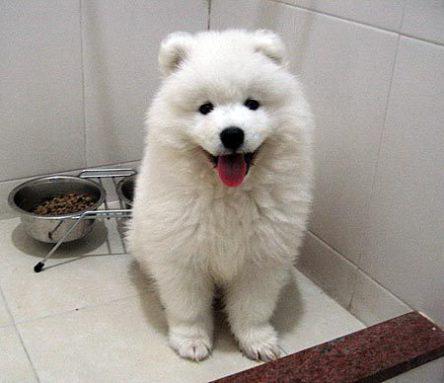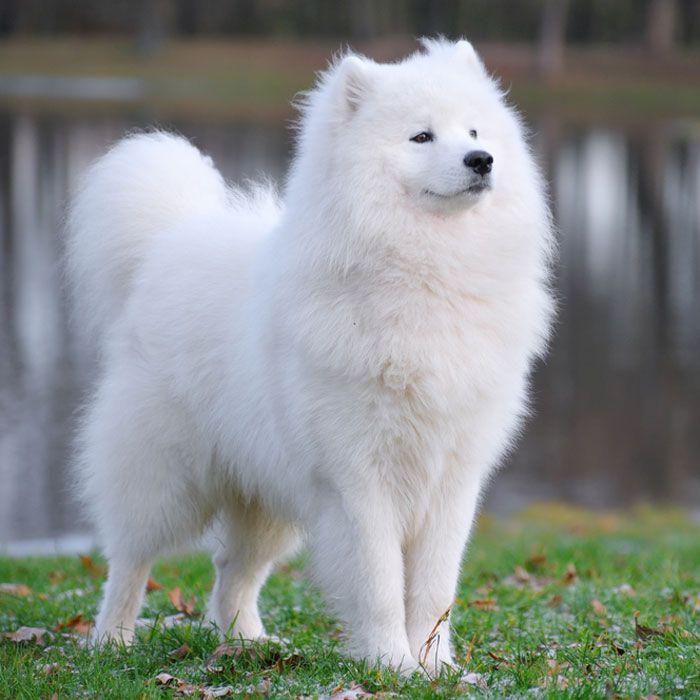The first image is the image on the left, the second image is the image on the right. Considering the images on both sides, is "There are at least two dogs in the image on the left" valid? Answer yes or no. No. The first image is the image on the left, the second image is the image on the right. Evaluate the accuracy of this statement regarding the images: "One image contains at least two dogs.". Is it true? Answer yes or no. No. 